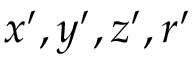Convert formula to latex. <formula><loc_0><loc_0><loc_500><loc_500>x ^ { \prime } , y ^ { \prime } , z ^ { \prime } , r ^ { \prime }</formula> 